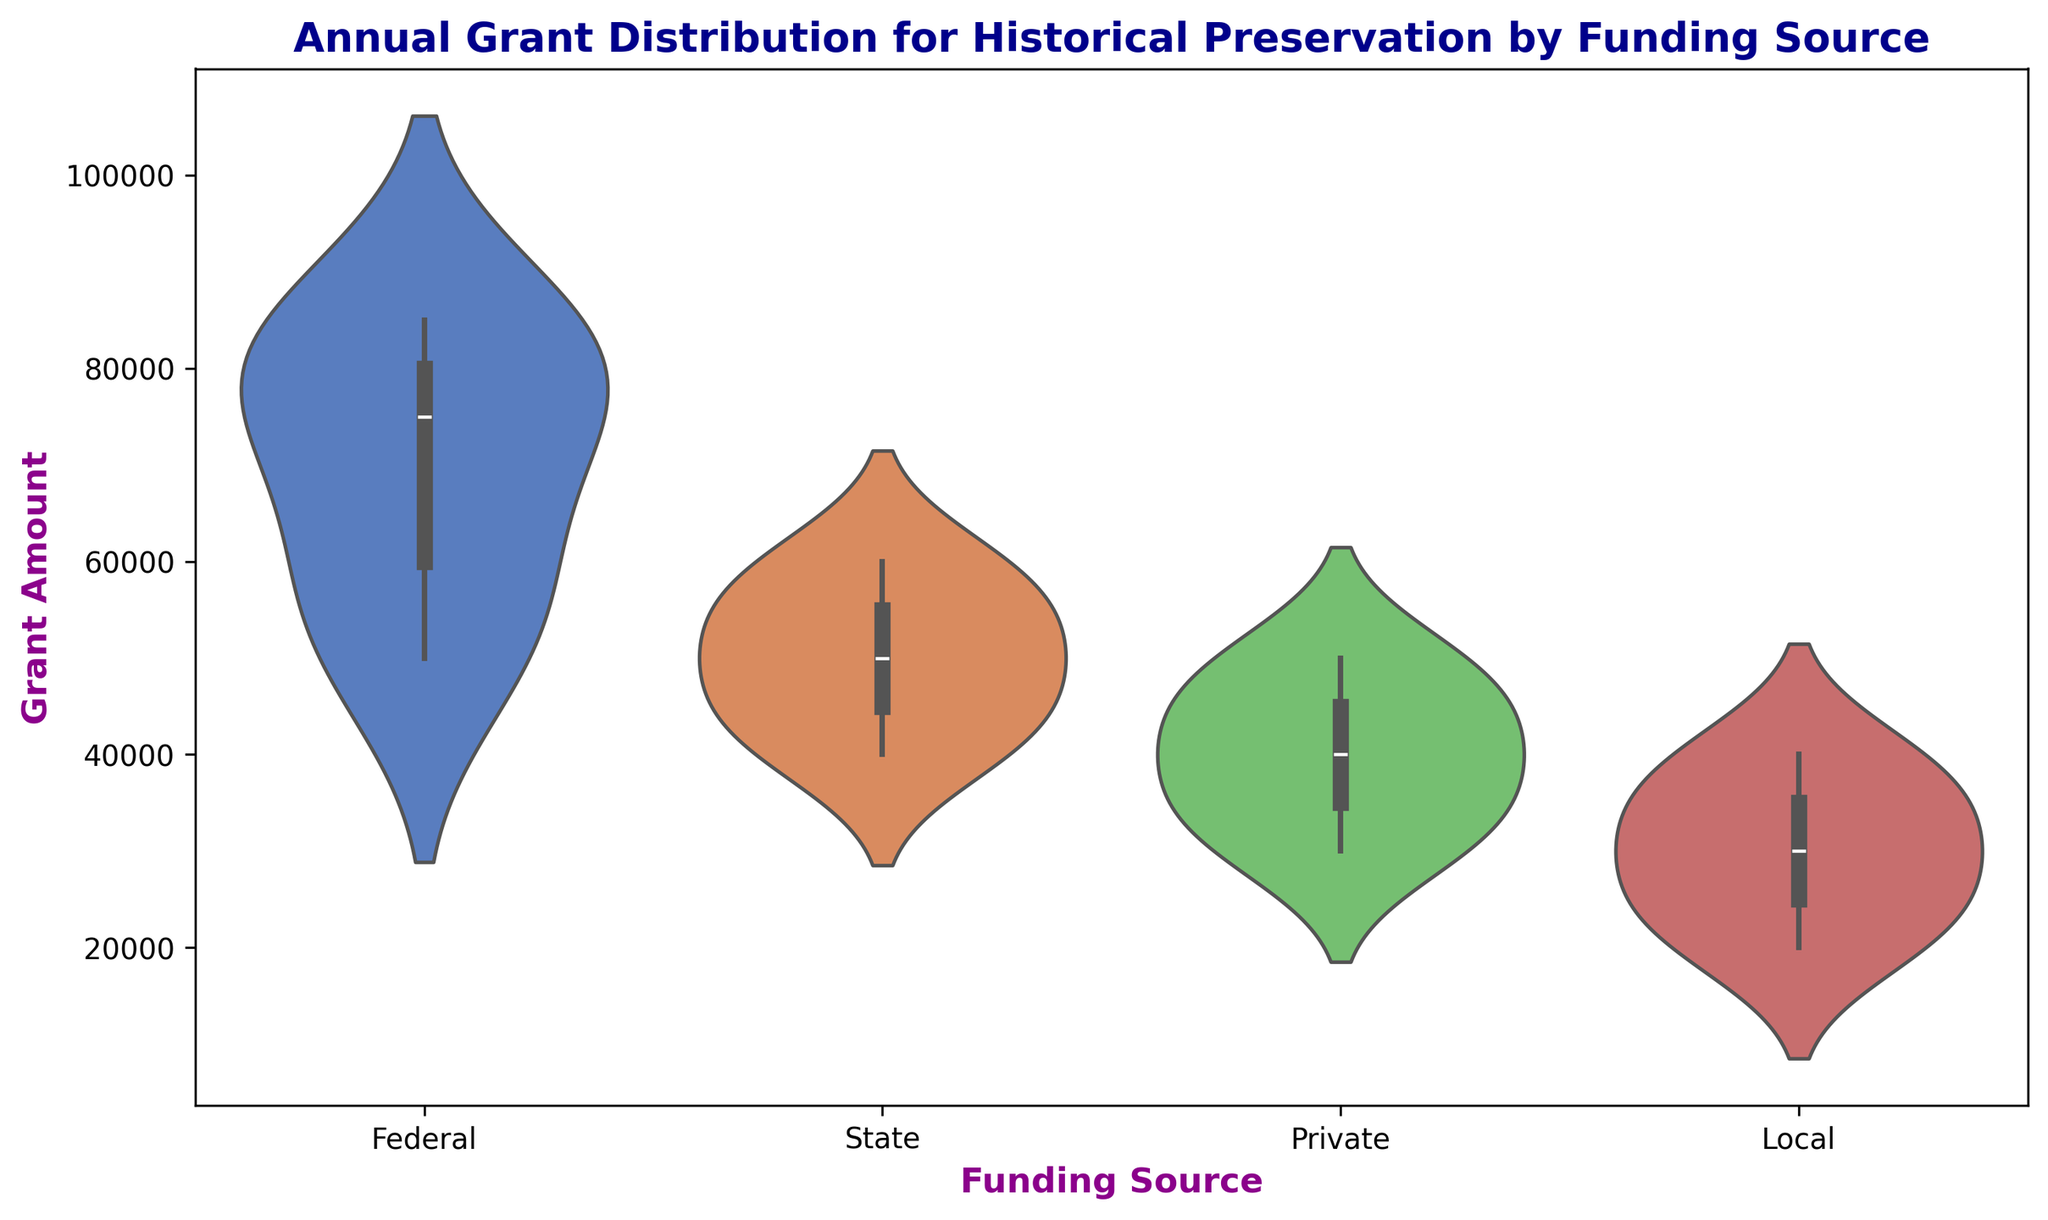What funding source has the highest median grant amount? Looking at the violin plot, visually compare the median lines within each violin. The one with the highest median line will have the highest median grant amount.
Answer: Federal Which funding source shows the widest range of grant amounts? Observe the height of each 'violin' across all funding sources. The one that covers the largest range from top to bottom vertically has the widest range of grant amounts.
Answer: Federal How do the median grant amounts of State and Local funding compare? Compare the horizontal lines inside the violins for State and Local funding. Visually, check which median line is higher.
Answer: State has a higher median than Local By how much does the median grant amount of Federal funding exceed that of Private funding? Identify the location of the median lines within the violins for Federal and Private funding and calculate the difference in their values.
Answer: Federal median exceeds Private by $20,000 Which funding source has the lowest maximum grant amount? Look at the top edges of all the violins to find the one that extends the least amount upwards, representing the lowest maximum grant amount.
Answer: Local What is the average of the median grant amounts across all funding sources? Find the median lines within each violin, note their values, and calculate the average of these median values. Federal (75000) + State (50000) + Private (40000) + Local (30000) = 195000/4 = 48750
Answer: $48,750 How do the distributions of Federal and Private funding differ visually? Federal has a wider and more spread out distribution, indicating a larger variability in grant amounts. Private is narrower and more concentrated, showing less variability.
Answer: Federal has more variability than Private Which funding source has the most consistent (least variable) grant amounts? Look for the violin with the narrowest width from top to bottom, indicating less variability in the data.
Answer: Local By how much did the maximum grant amount for Federal funding exceed the maximum for State funding? Compare the top edges of the Federal and State violins and calculate the difference in the maximum grant amounts.
Answer: $25,000 What can be inferred about the trends in grant distributions from the width of the violins? Wider sections in the middle indicate more frequency around certain grant amounts, while narrower sections suggest less frequency. This can be interpreted as where the bulk of the grant amounts lie for each funding source.
Answer: Width indicates frequency distribution 